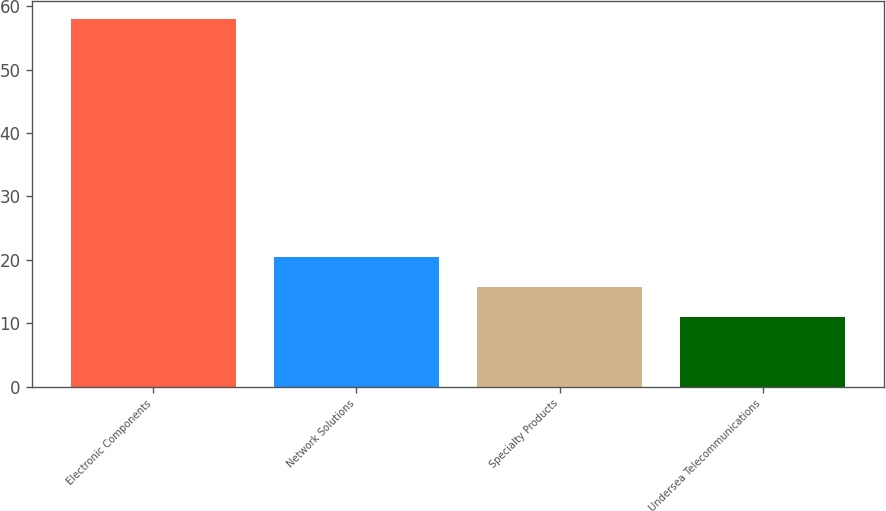<chart> <loc_0><loc_0><loc_500><loc_500><bar_chart><fcel>Electronic Components<fcel>Network Solutions<fcel>Specialty Products<fcel>Undersea Telecommunications<nl><fcel>58<fcel>20.4<fcel>15.7<fcel>11<nl></chart> 